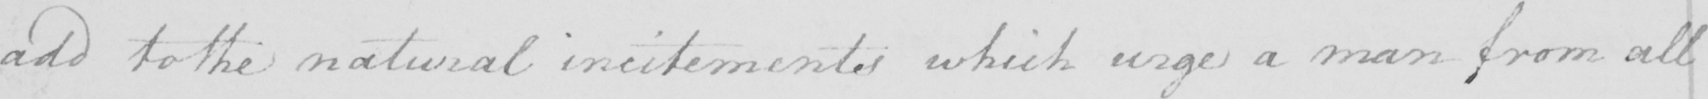What text is written in this handwritten line? add to the natural incitements which urge a man from all 